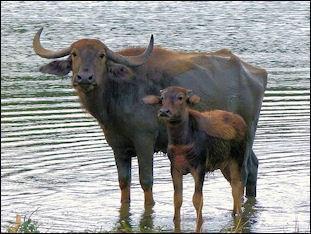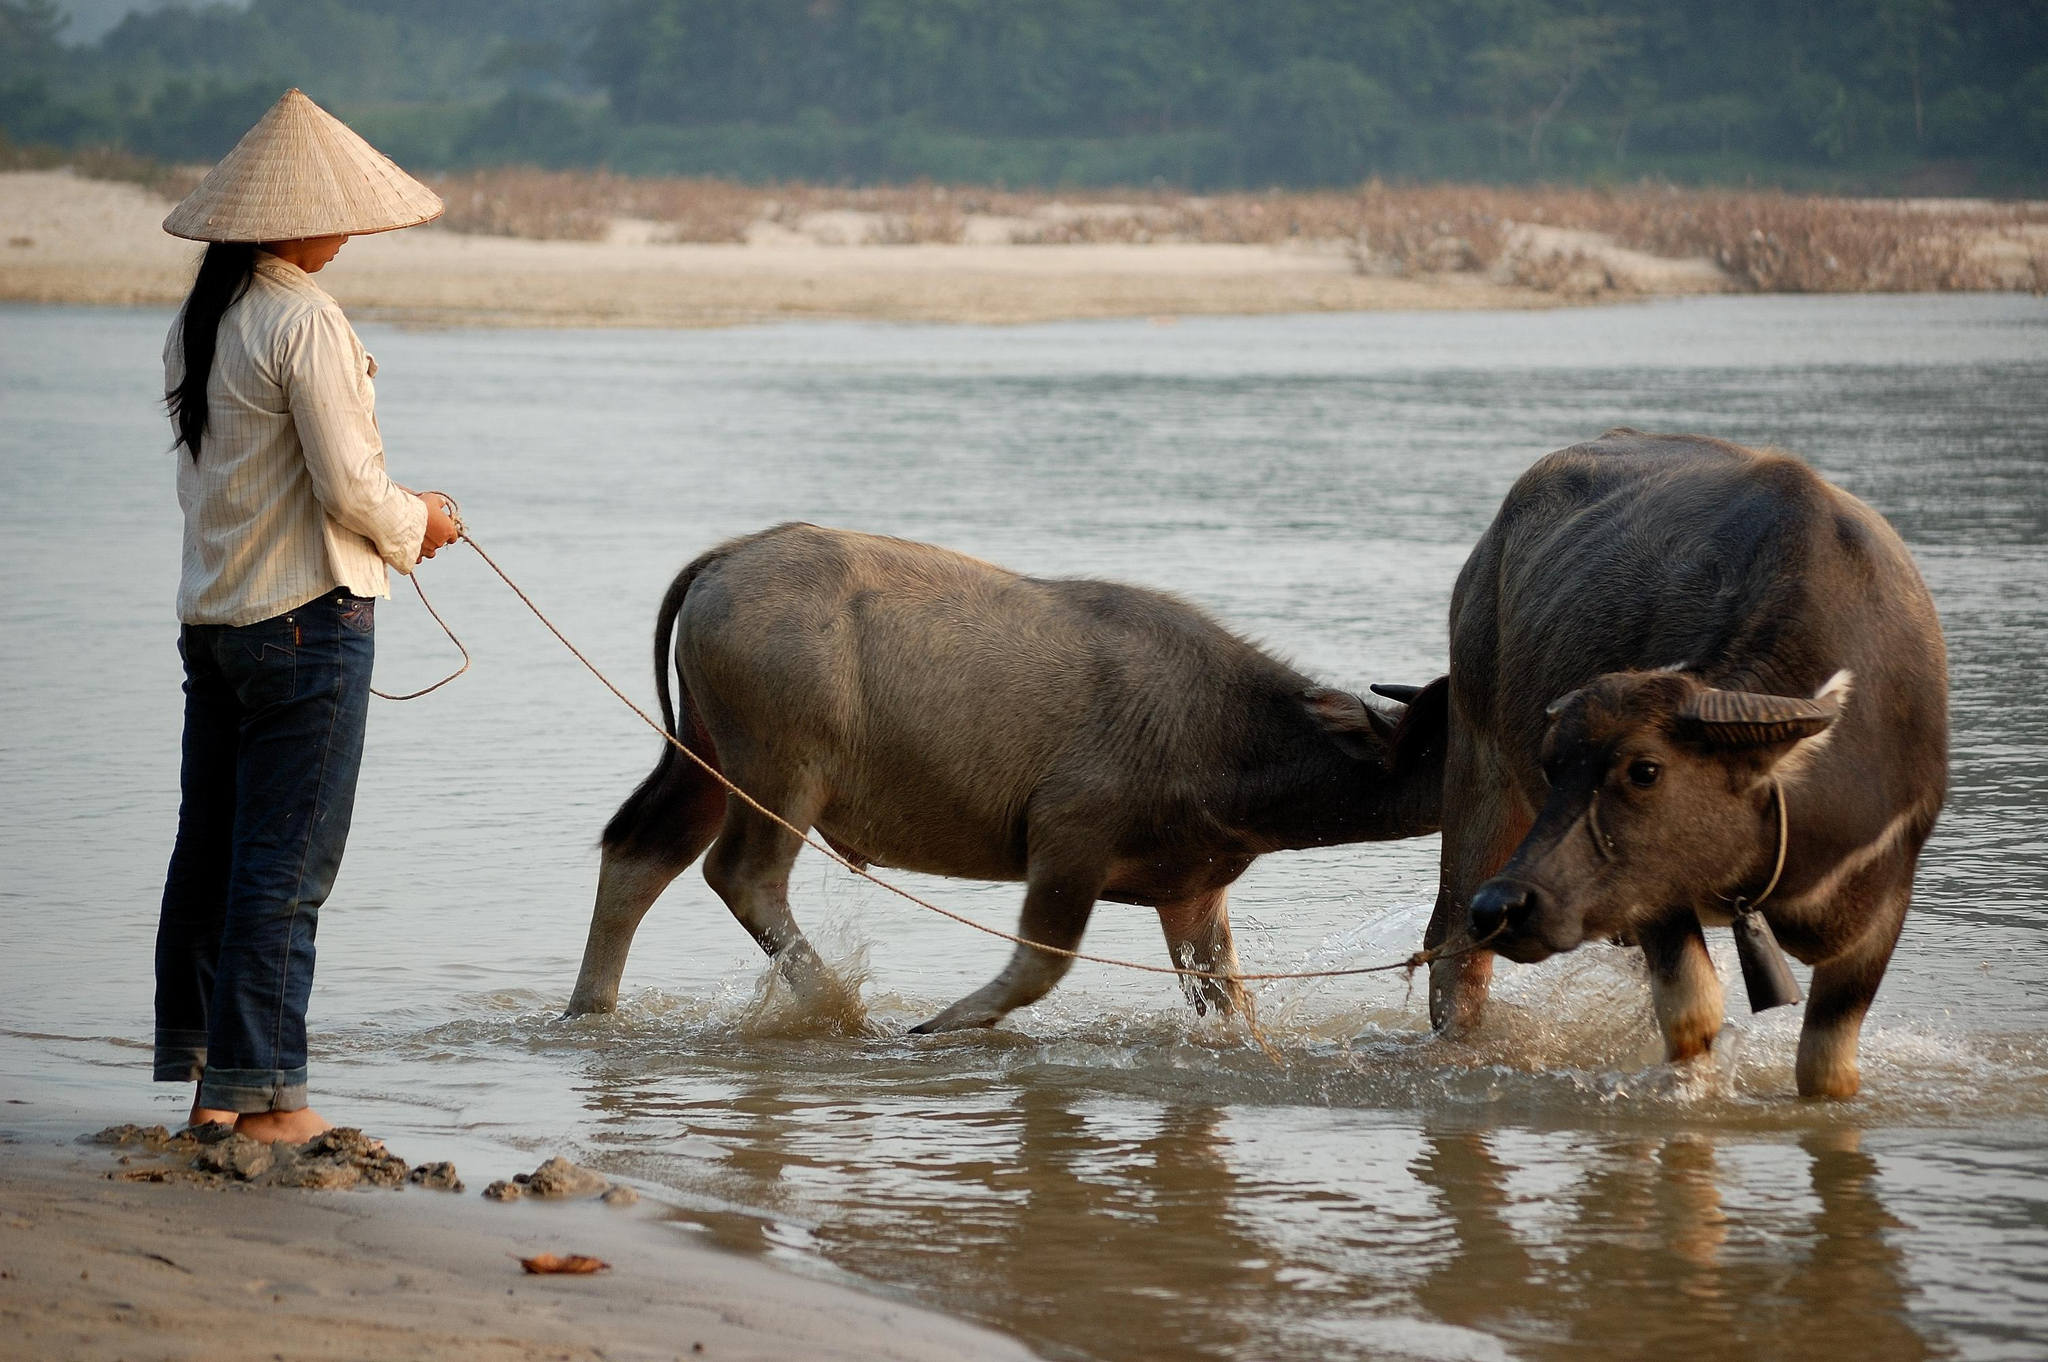The first image is the image on the left, the second image is the image on the right. Considering the images on both sides, is "There is exactly one animal in the image on the right." valid? Answer yes or no. No. The first image is the image on the left, the second image is the image on the right. Evaluate the accuracy of this statement regarding the images: "There is water visible in at least one of the images.". Is it true? Answer yes or no. Yes. 